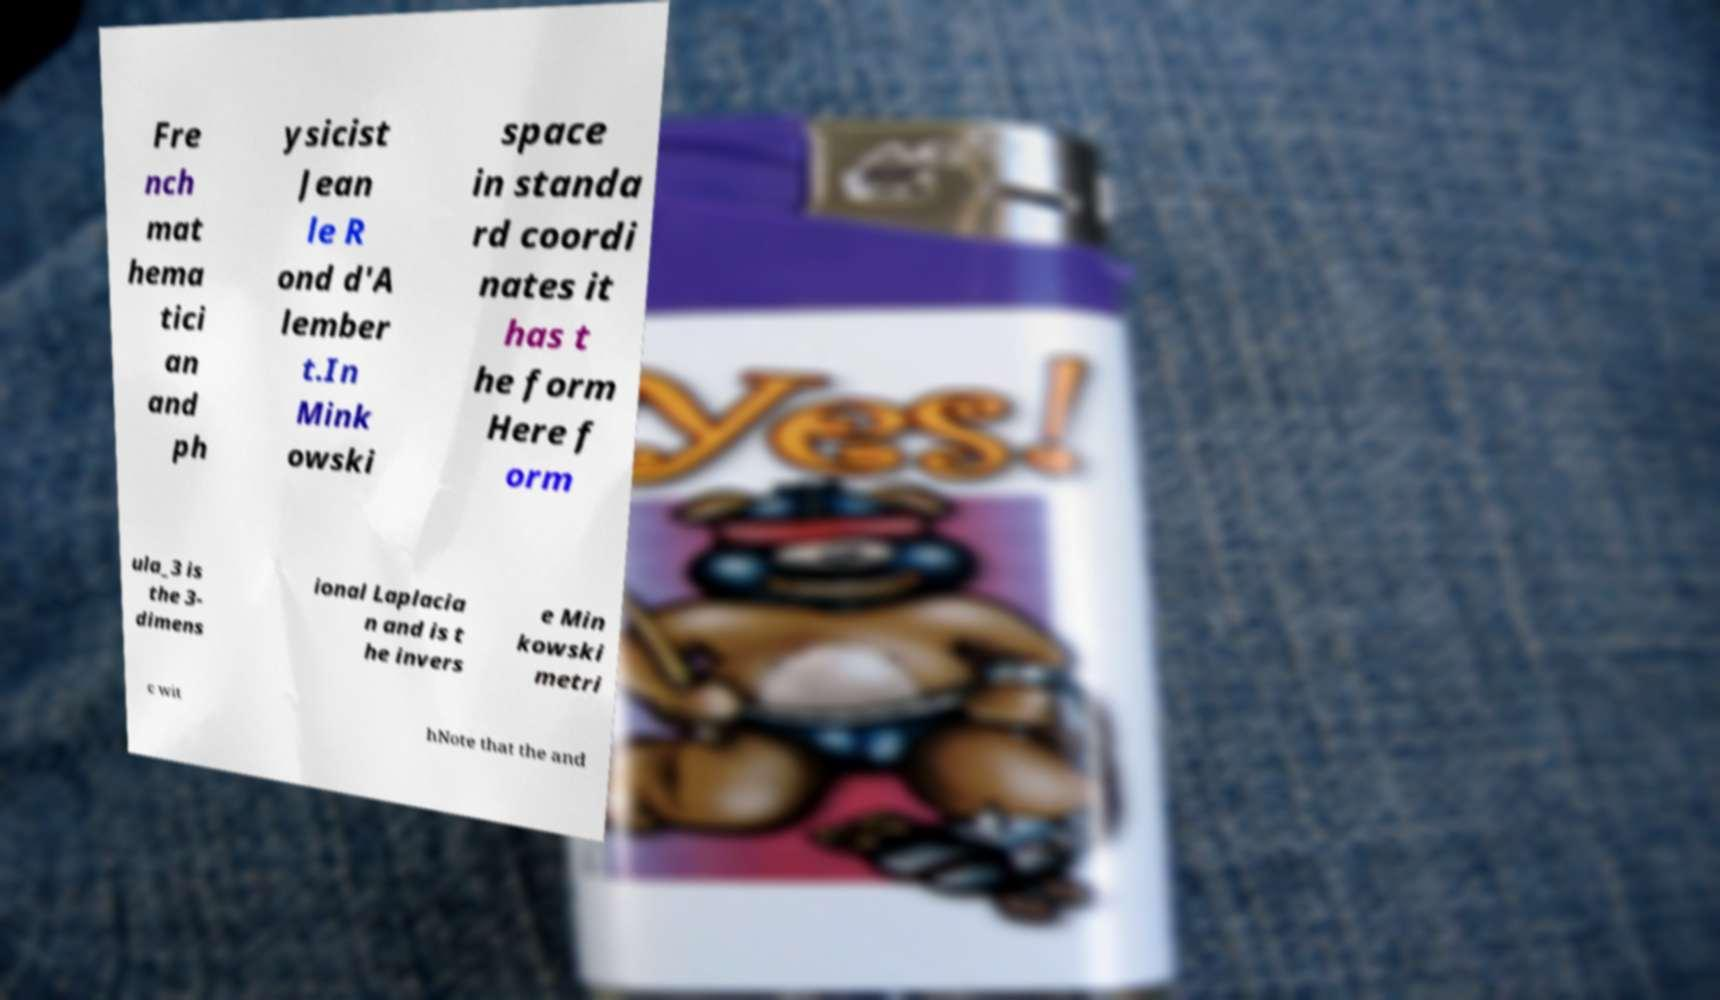Could you extract and type out the text from this image? Fre nch mat hema tici an and ph ysicist Jean le R ond d'A lember t.In Mink owski space in standa rd coordi nates it has t he form Here f orm ula_3 is the 3- dimens ional Laplacia n and is t he invers e Min kowski metri c wit hNote that the and 